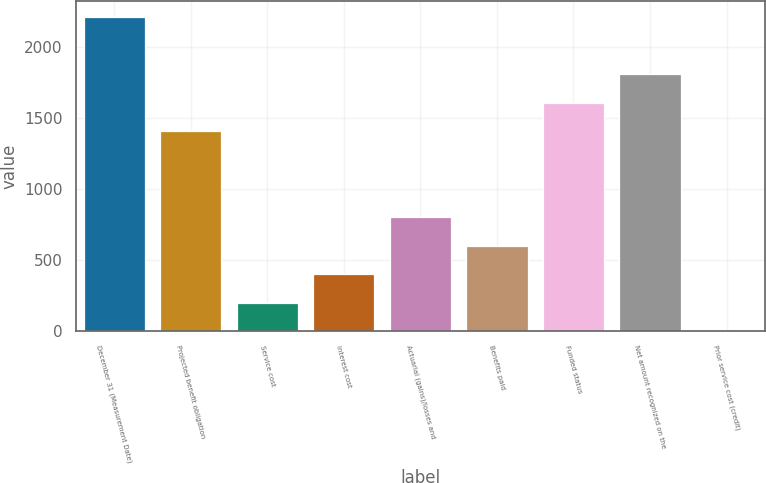Convert chart to OTSL. <chart><loc_0><loc_0><loc_500><loc_500><bar_chart><fcel>December 31 (Measurement Date)<fcel>Projected benefit obligation<fcel>Service cost<fcel>Interest cost<fcel>Actuarial (gains)/losses and<fcel>Benefits paid<fcel>Funded status<fcel>Net amount recognized on the<fcel>Prior service cost (credit)<nl><fcel>2214.2<fcel>1409.4<fcel>202.2<fcel>403.4<fcel>805.8<fcel>604.6<fcel>1610.6<fcel>1811.8<fcel>1<nl></chart> 